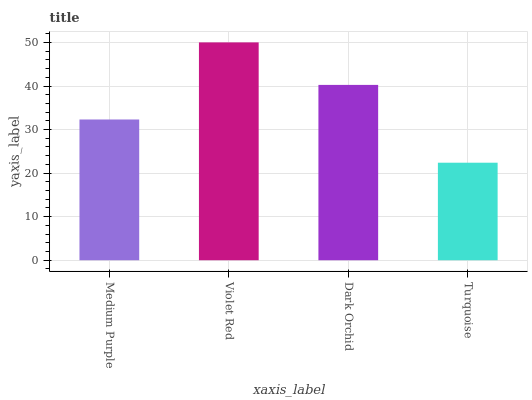Is Turquoise the minimum?
Answer yes or no. Yes. Is Violet Red the maximum?
Answer yes or no. Yes. Is Dark Orchid the minimum?
Answer yes or no. No. Is Dark Orchid the maximum?
Answer yes or no. No. Is Violet Red greater than Dark Orchid?
Answer yes or no. Yes. Is Dark Orchid less than Violet Red?
Answer yes or no. Yes. Is Dark Orchid greater than Violet Red?
Answer yes or no. No. Is Violet Red less than Dark Orchid?
Answer yes or no. No. Is Dark Orchid the high median?
Answer yes or no. Yes. Is Medium Purple the low median?
Answer yes or no. Yes. Is Medium Purple the high median?
Answer yes or no. No. Is Violet Red the low median?
Answer yes or no. No. 